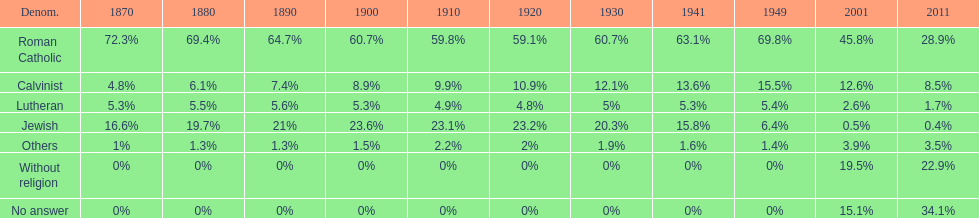How many denominations never dropped below 20%? 1. 